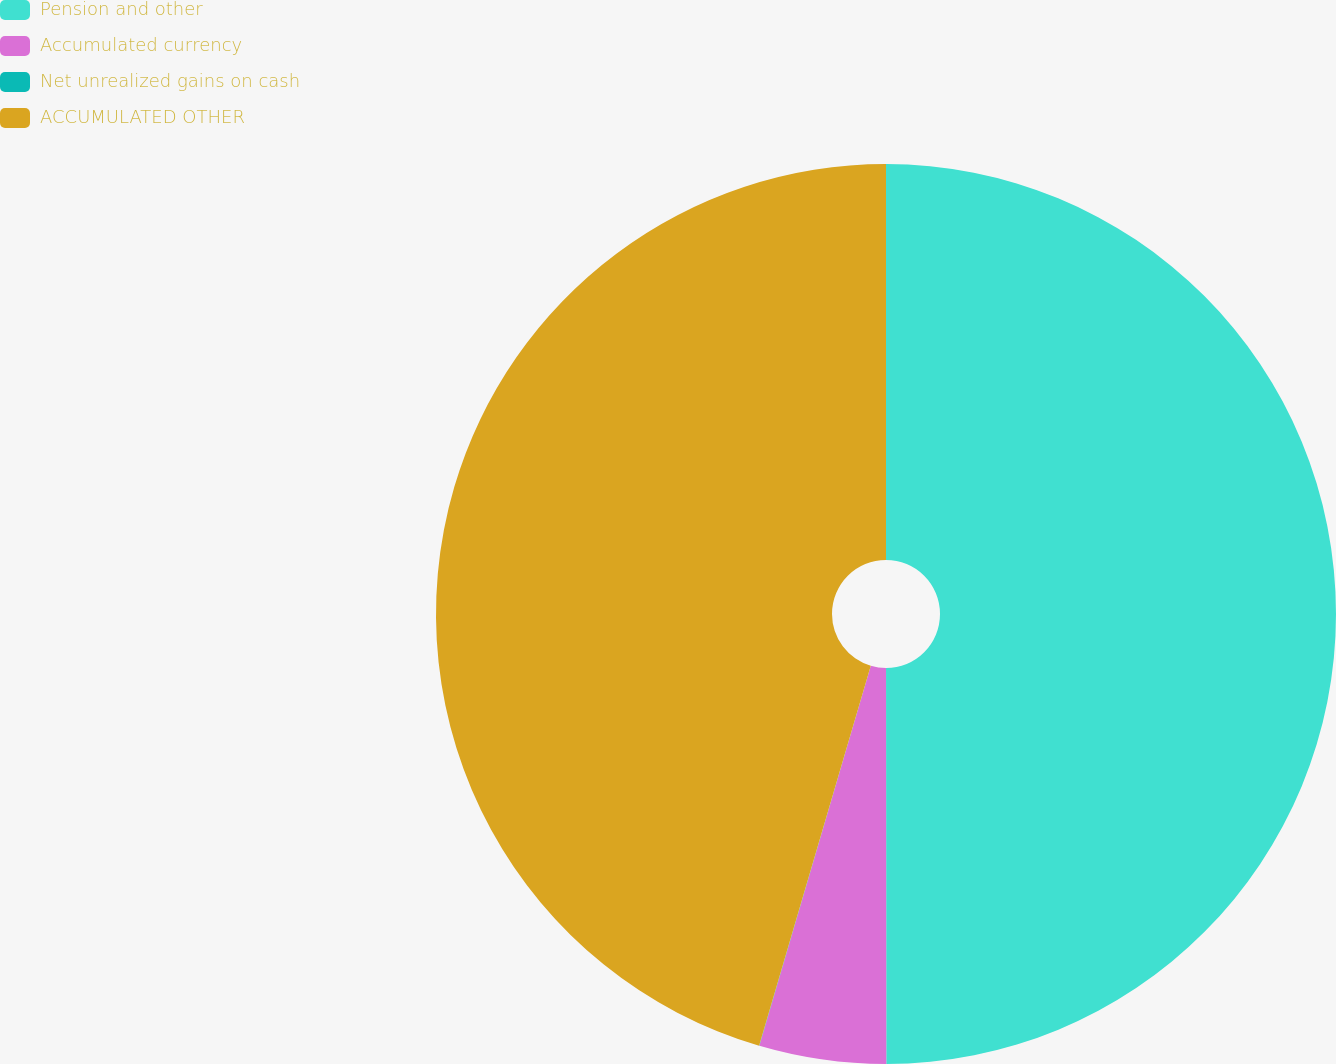Convert chart. <chart><loc_0><loc_0><loc_500><loc_500><pie_chart><fcel>Pension and other<fcel>Accumulated currency<fcel>Net unrealized gains on cash<fcel>ACCUMULATED OTHER<nl><fcel>49.99%<fcel>4.55%<fcel>0.01%<fcel>45.45%<nl></chart> 